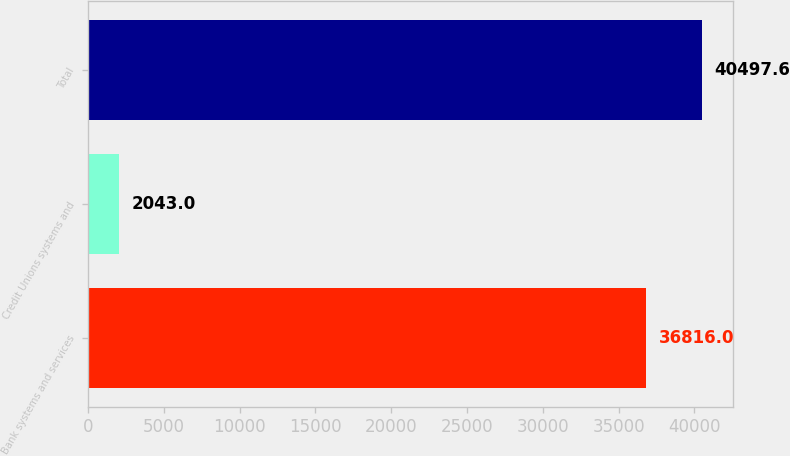<chart> <loc_0><loc_0><loc_500><loc_500><bar_chart><fcel>Bank systems and services<fcel>Credit Unions systems and<fcel>Total<nl><fcel>36816<fcel>2043<fcel>40497.6<nl></chart> 